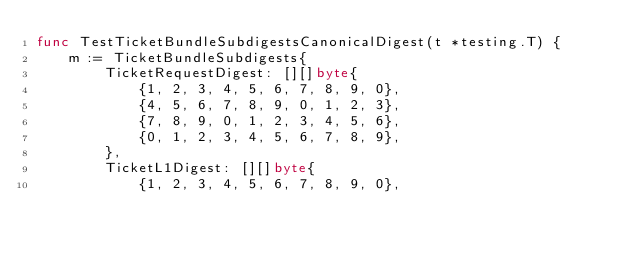Convert code to text. <code><loc_0><loc_0><loc_500><loc_500><_Go_>func TestTicketBundleSubdigestsCanonicalDigest(t *testing.T) {
	m := TicketBundleSubdigests{
		TicketRequestDigest: [][]byte{
			{1, 2, 3, 4, 5, 6, 7, 8, 9, 0},
			{4, 5, 6, 7, 8, 9, 0, 1, 2, 3},
			{7, 8, 9, 0, 1, 2, 3, 4, 5, 6},
			{0, 1, 2, 3, 4, 5, 6, 7, 8, 9},
		},
		TicketL1Digest: [][]byte{
			{1, 2, 3, 4, 5, 6, 7, 8, 9, 0},</code> 